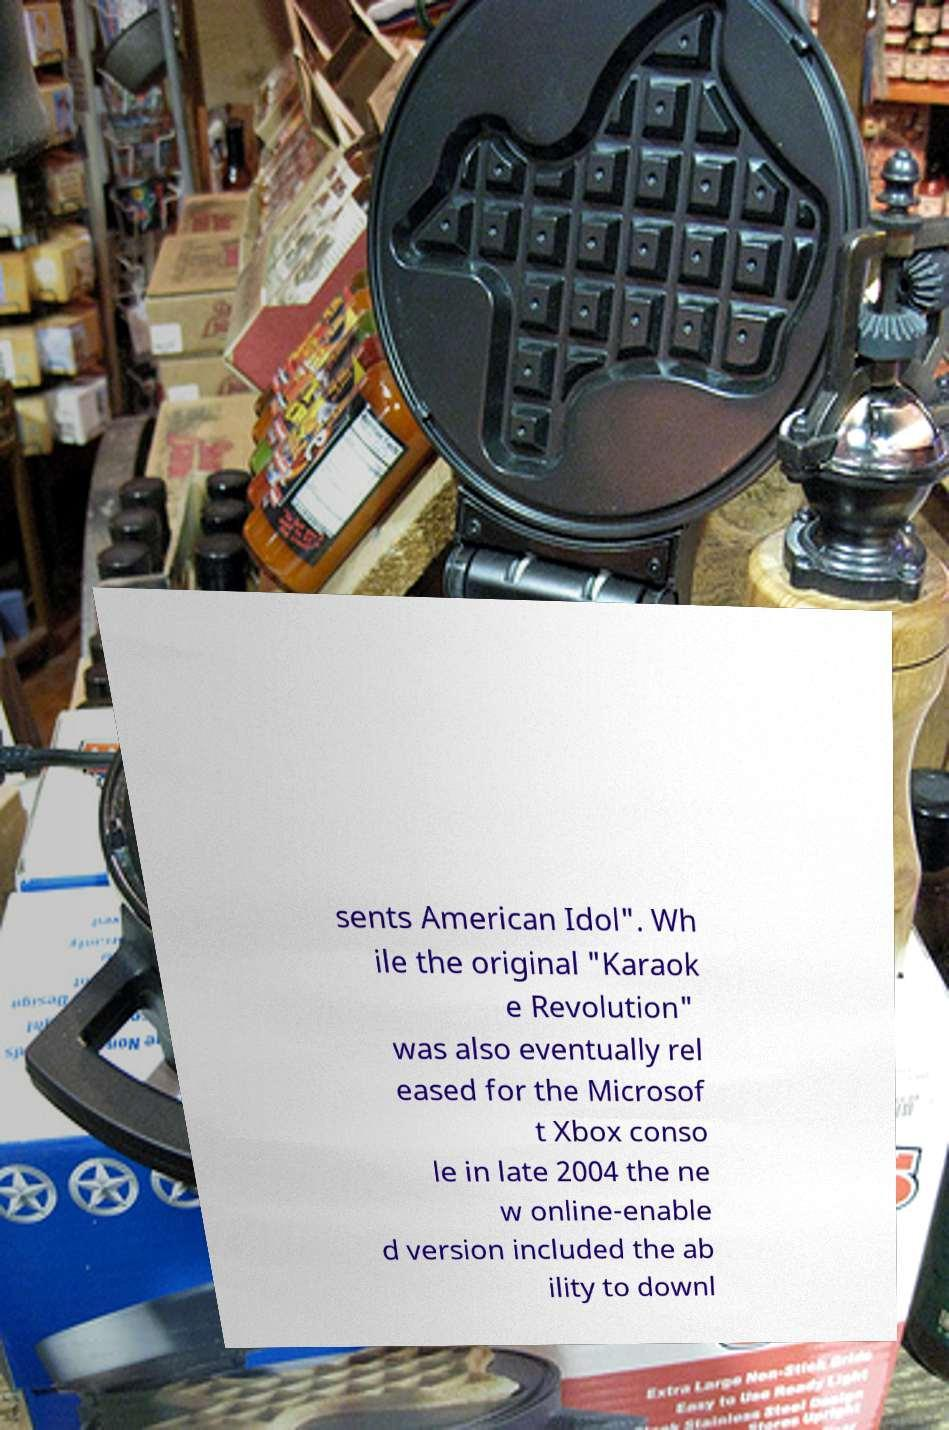Can you accurately transcribe the text from the provided image for me? sents American Idol". Wh ile the original "Karaok e Revolution" was also eventually rel eased for the Microsof t Xbox conso le in late 2004 the ne w online-enable d version included the ab ility to downl 